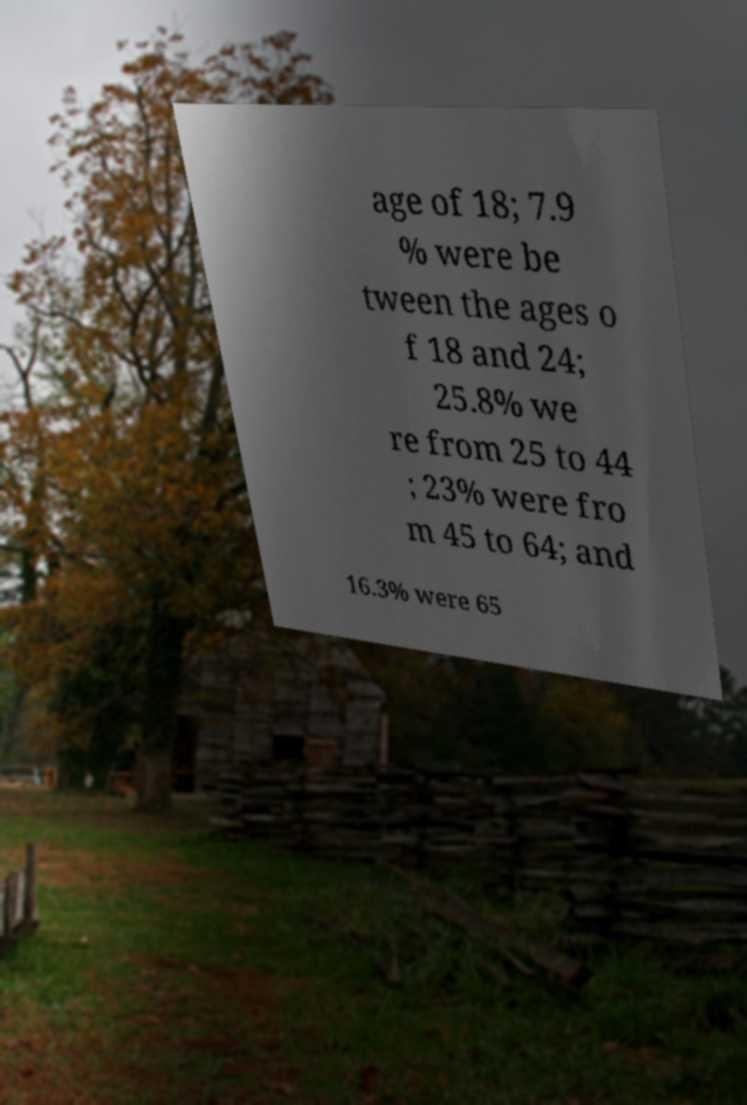Please identify and transcribe the text found in this image. age of 18; 7.9 % were be tween the ages o f 18 and 24; 25.8% we re from 25 to 44 ; 23% were fro m 45 to 64; and 16.3% were 65 